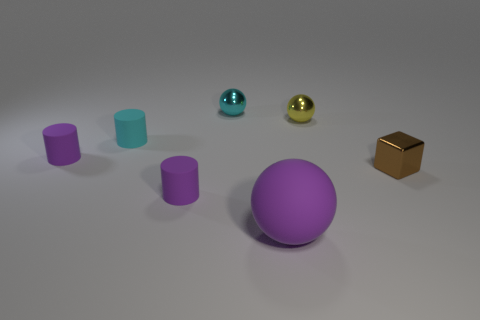Subtract all blue cubes. Subtract all yellow balls. How many cubes are left? 1 Add 2 tiny gray cylinders. How many objects exist? 9 Subtract all blocks. How many objects are left? 6 Add 1 brown shiny blocks. How many brown shiny blocks exist? 2 Subtract 0 brown cylinders. How many objects are left? 7 Subtract all tiny shiny cubes. Subtract all tiny cyan matte objects. How many objects are left? 5 Add 1 big rubber things. How many big rubber things are left? 2 